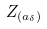Convert formula to latex. <formula><loc_0><loc_0><loc_500><loc_500>Z _ { ( a _ { \delta } ) }</formula> 